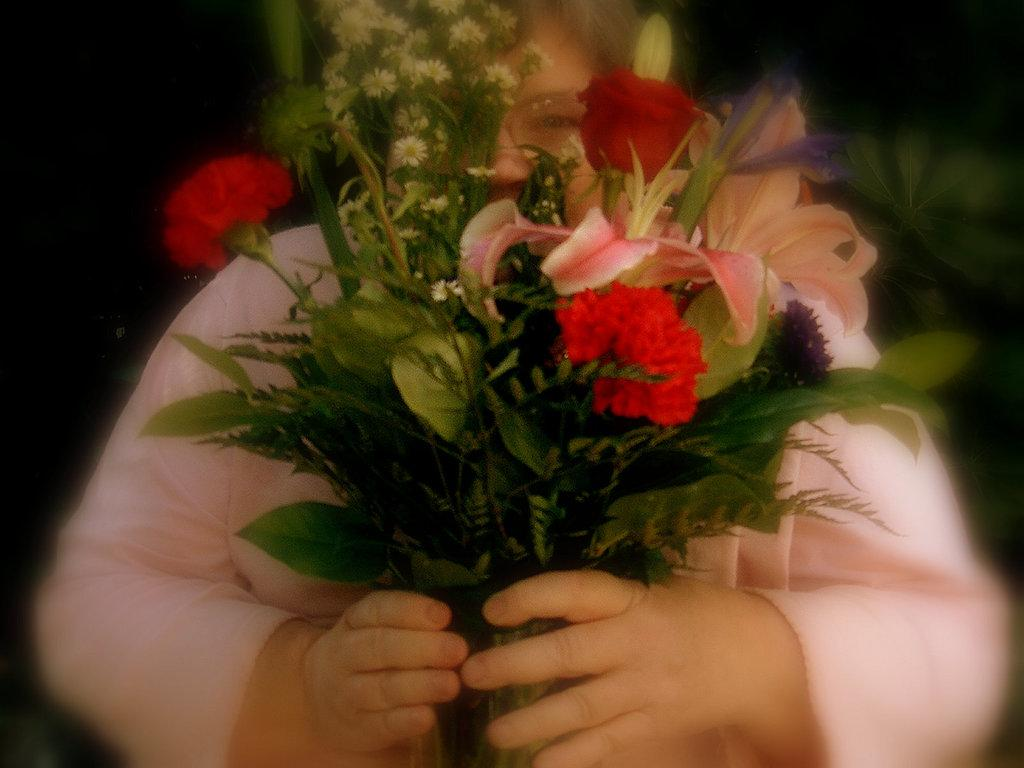Who or what is the main subject in the image? There is a person in the image. What is the person holding? The person is holding a bouquet. Where is the bouquet located in relation to the person? The bouquet is in the center of the image. How many kittens are visible in the image? There are no kittens present in the image. 